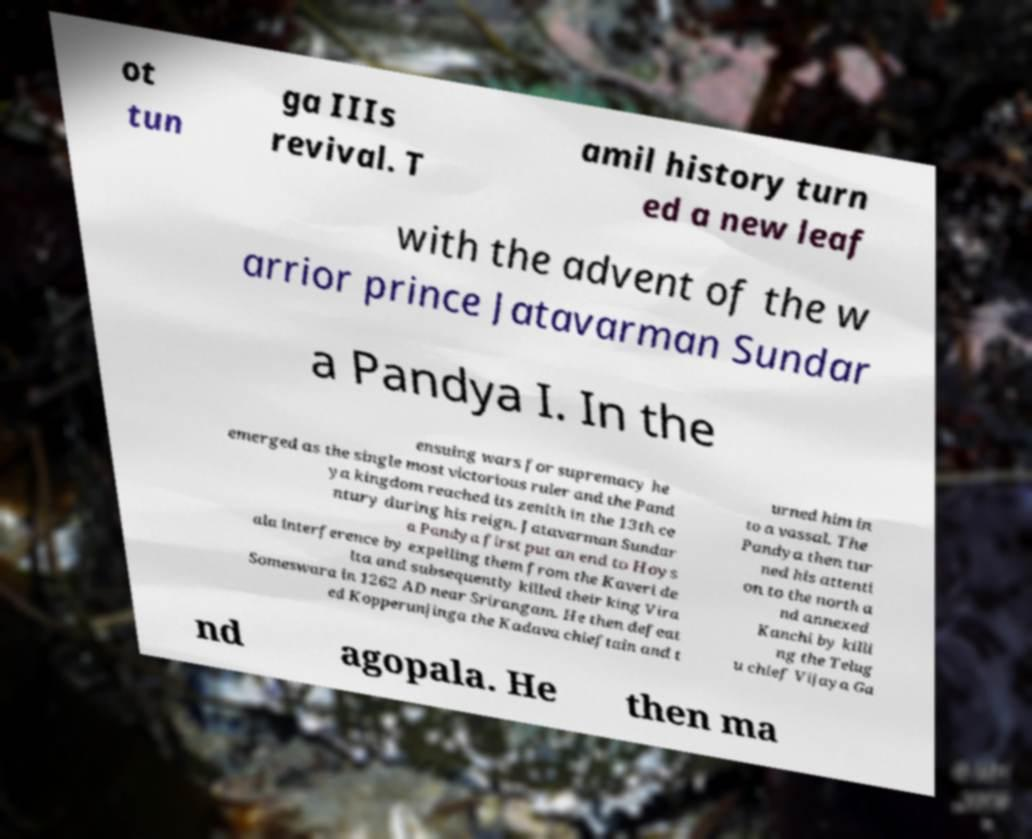Can you accurately transcribe the text from the provided image for me? ot tun ga IIIs revival. T amil history turn ed a new leaf with the advent of the w arrior prince Jatavarman Sundar a Pandya I. In the ensuing wars for supremacy he emerged as the single most victorious ruler and the Pand ya kingdom reached its zenith in the 13th ce ntury during his reign. Jatavarman Sundar a Pandya first put an end to Hoys ala interference by expelling them from the Kaveri de lta and subsequently killed their king Vira Someswara in 1262 AD near Srirangam. He then defeat ed Kopperunjinga the Kadava chieftain and t urned him in to a vassal. The Pandya then tur ned his attenti on to the north a nd annexed Kanchi by killi ng the Telug u chief Vijaya Ga nd agopala. He then ma 